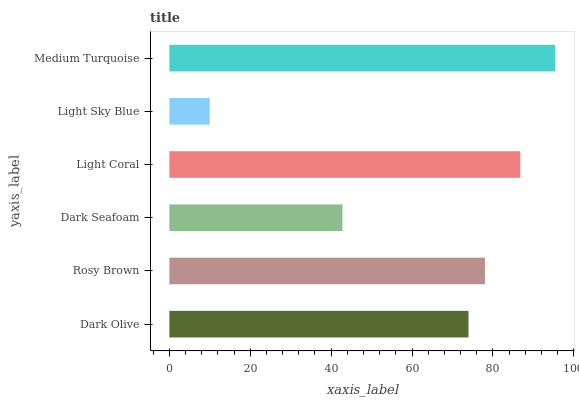Is Light Sky Blue the minimum?
Answer yes or no. Yes. Is Medium Turquoise the maximum?
Answer yes or no. Yes. Is Rosy Brown the minimum?
Answer yes or no. No. Is Rosy Brown the maximum?
Answer yes or no. No. Is Rosy Brown greater than Dark Olive?
Answer yes or no. Yes. Is Dark Olive less than Rosy Brown?
Answer yes or no. Yes. Is Dark Olive greater than Rosy Brown?
Answer yes or no. No. Is Rosy Brown less than Dark Olive?
Answer yes or no. No. Is Rosy Brown the high median?
Answer yes or no. Yes. Is Dark Olive the low median?
Answer yes or no. Yes. Is Light Coral the high median?
Answer yes or no. No. Is Light Sky Blue the low median?
Answer yes or no. No. 